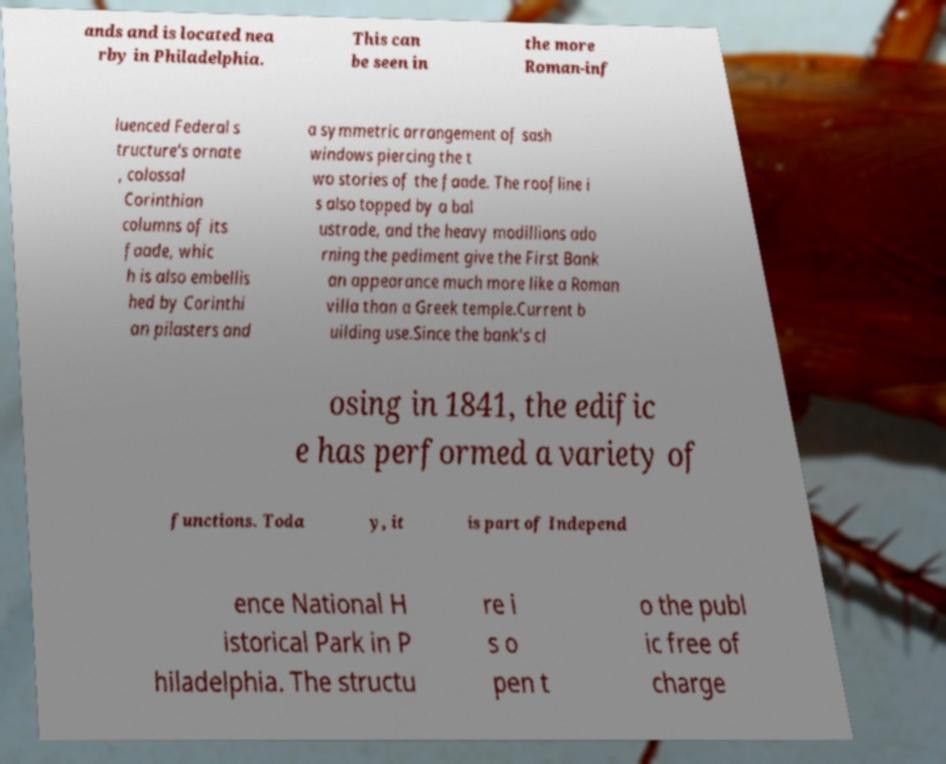For documentation purposes, I need the text within this image transcribed. Could you provide that? ands and is located nea rby in Philadelphia. This can be seen in the more Roman-inf luenced Federal s tructure's ornate , colossal Corinthian columns of its faade, whic h is also embellis hed by Corinthi an pilasters and a symmetric arrangement of sash windows piercing the t wo stories of the faade. The roofline i s also topped by a bal ustrade, and the heavy modillions ado rning the pediment give the First Bank an appearance much more like a Roman villa than a Greek temple.Current b uilding use.Since the bank's cl osing in 1841, the edific e has performed a variety of functions. Toda y, it is part of Independ ence National H istorical Park in P hiladelphia. The structu re i s o pen t o the publ ic free of charge 